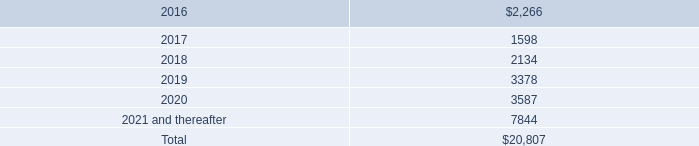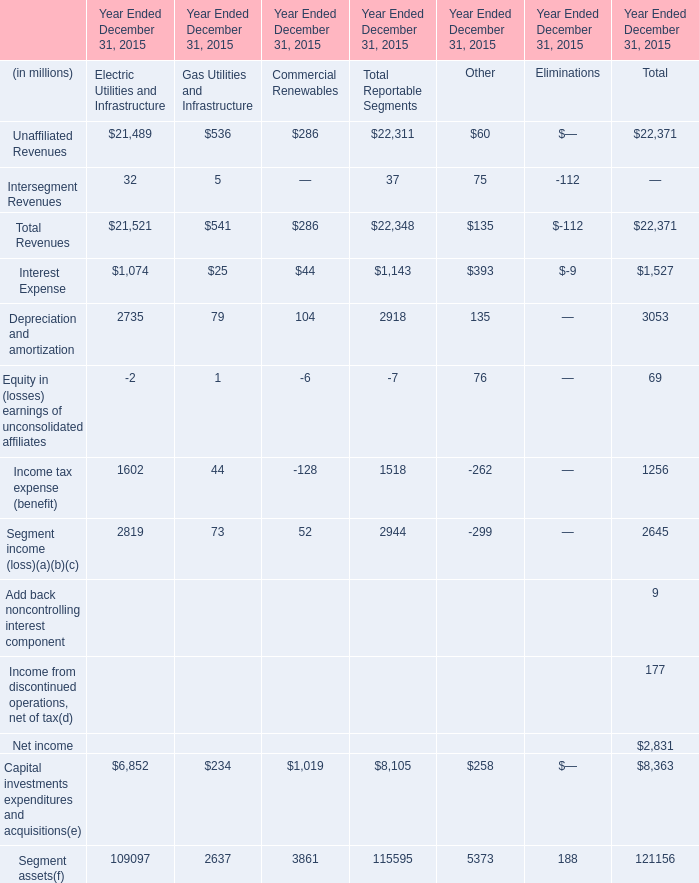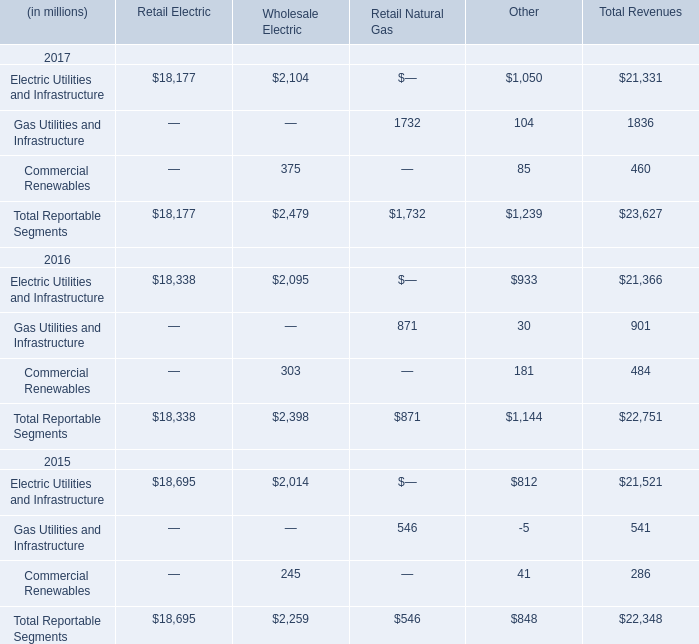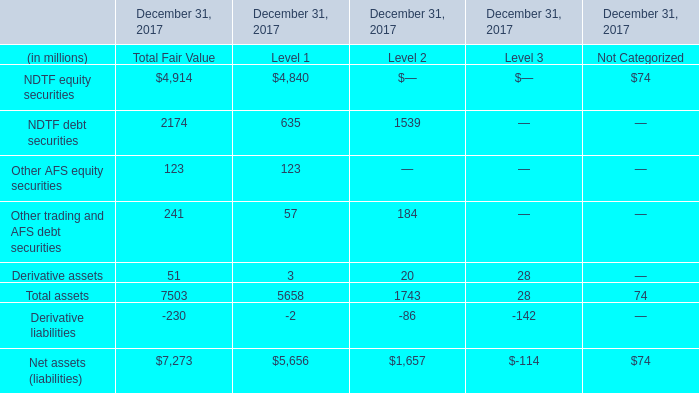What's the sum of all Other that are greater than 0 in 2015? (in million) 
Computations: (((((60 + 75) + 393) + 135) + 76) + 5373)
Answer: 6112.0. 